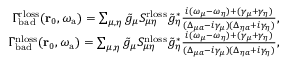Convert formula to latex. <formula><loc_0><loc_0><loc_500><loc_500>\begin{array} { r } { \Gamma _ { b a d } ^ { r l o s s } ( r _ { 0 } , { \omega _ { a } } ) = \sum _ { \mu , \eta } \tilde { g } _ { \mu } S _ { \mu \eta } ^ { r l o s s } \tilde { g } _ { \eta } ^ { * } \frac { i ( \omega _ { \mu } - \omega _ { \eta } ) + ( \gamma _ { \mu } + \gamma _ { \eta } ) } { ( \Delta _ { \mu a } - i \gamma _ { \mu } ) ( \Delta _ { \eta a } + i \gamma _ { \eta } ) } , } \\ { \Gamma _ { b a d } ^ { n l o s s } ( r _ { 0 } , { \omega _ { a } } ) = \sum _ { \mu , \eta } \tilde { g } _ { \mu } S _ { \mu \eta } ^ { n l o s s } \tilde { g } _ { \eta } ^ { * } \frac { i ( \omega _ { \mu } - \omega _ { \eta } ) + ( \gamma _ { \mu } + \gamma _ { \eta } ) } { ( \Delta _ { \mu a } - i \gamma _ { \mu } ) ( \Delta _ { \eta a } + i \gamma _ { \eta } ) } , } \end{array}</formula> 